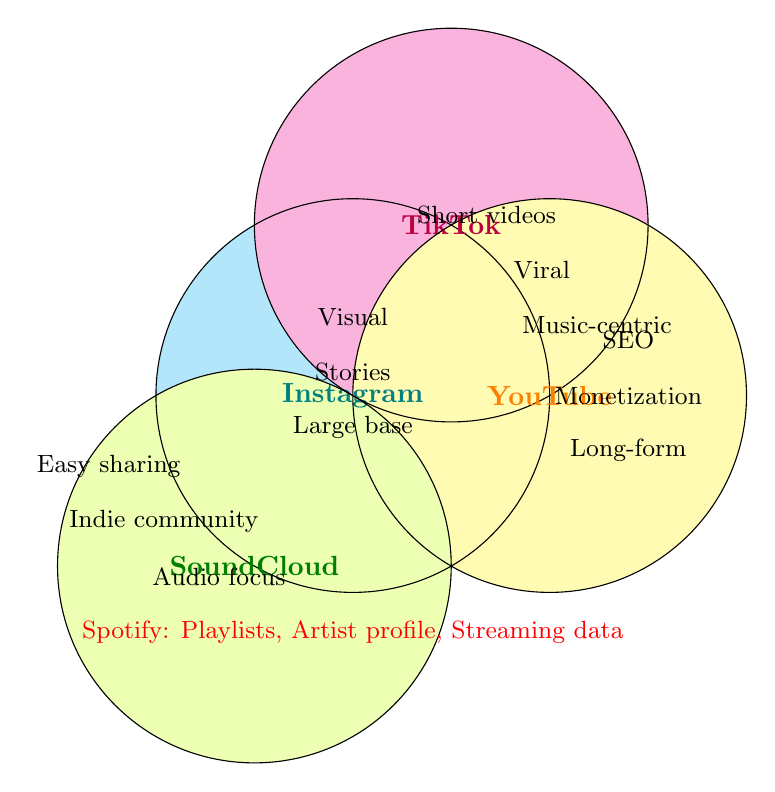What platforms are highlighted in the Venn Diagram? The platforms are the titles of the different circles in the diagram.
Answer: Instagram, TikTok, YouTube, SoundCloud What feature is unique to Instagram according to the diagram? Only Instagram has visual content as a feature in its circle.
Answer: Visual content Which platform is associated with short-form videos? The feature is found in the circle labeled TikTok.
Answer: TikTok Does YouTube have a music-centric focus according to the diagram? No, the music-centric feature is associated with TikTok.
Answer: No Which platform has an indie artist community? This feature is located within the SoundCloud circle.
Answer: SoundCloud What are the common features between Instagram and TikTok, if any? Look at the overlapping area between the circles of Instagram and TikTok.
Answer: None What feature sets Spotify apart from the other platforms in the diagram? The Spotify text at the bottom states its unique features: Playlists, Artist profile, Streaming data.
Answer: Playlists, Artist profile, Streaming data Which platform focuses on long-form content? This feature is within the YouTube circle.
Answer: YouTube How many features are listed for TikTok in the diagram? Count the number of features in the TikTok circle.
Answer: 3 Which two platforms are both listed as having large user bases based on the diagram's visual information? Only Instagram is indicated to have a large user base; no other platform shares this feature in the diagram.
Answer: Instagram only 